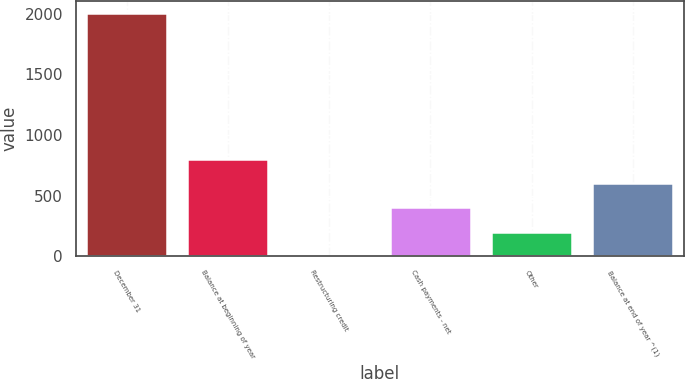Convert chart to OTSL. <chart><loc_0><loc_0><loc_500><loc_500><bar_chart><fcel>December 31<fcel>Balance at beginning of year<fcel>Restructuring credit<fcel>Cash payments - net<fcel>Other<fcel>Balance at end of year ^(1)<nl><fcel>2006<fcel>804.2<fcel>3<fcel>403.6<fcel>203.3<fcel>603.9<nl></chart> 